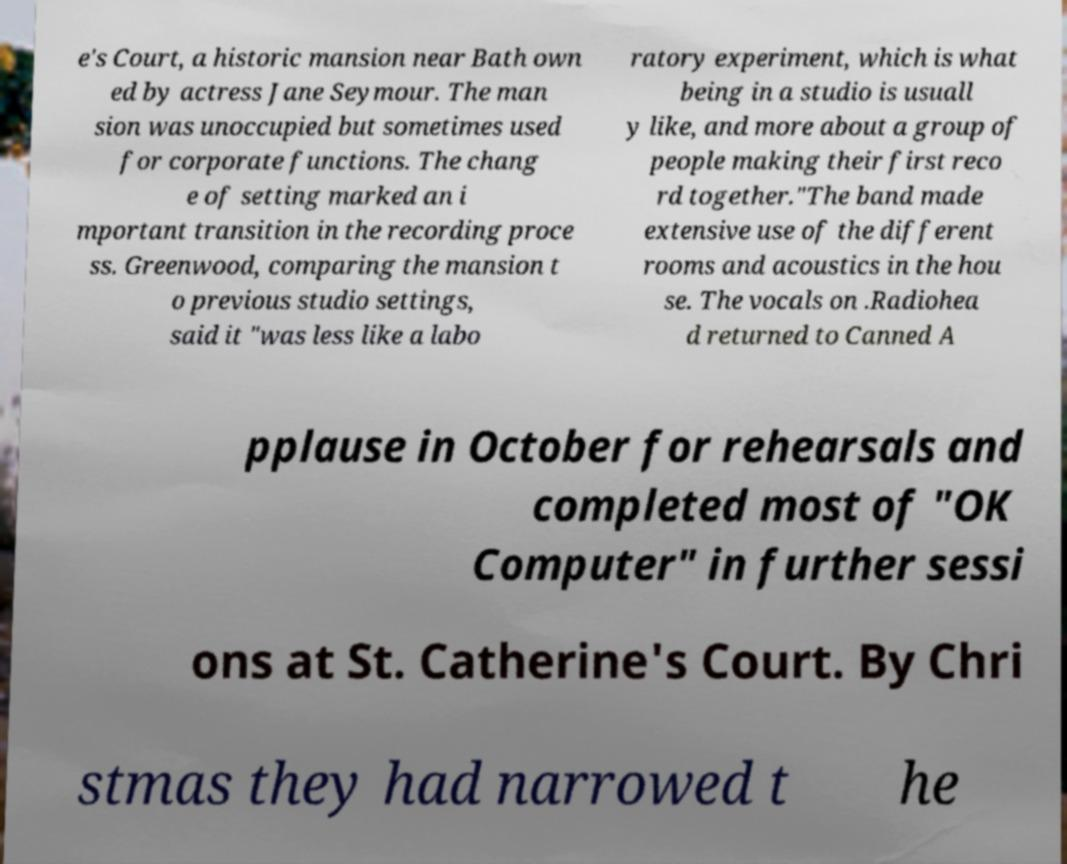Please identify and transcribe the text found in this image. e's Court, a historic mansion near Bath own ed by actress Jane Seymour. The man sion was unoccupied but sometimes used for corporate functions. The chang e of setting marked an i mportant transition in the recording proce ss. Greenwood, comparing the mansion t o previous studio settings, said it "was less like a labo ratory experiment, which is what being in a studio is usuall y like, and more about a group of people making their first reco rd together."The band made extensive use of the different rooms and acoustics in the hou se. The vocals on .Radiohea d returned to Canned A pplause in October for rehearsals and completed most of "OK Computer" in further sessi ons at St. Catherine's Court. By Chri stmas they had narrowed t he 